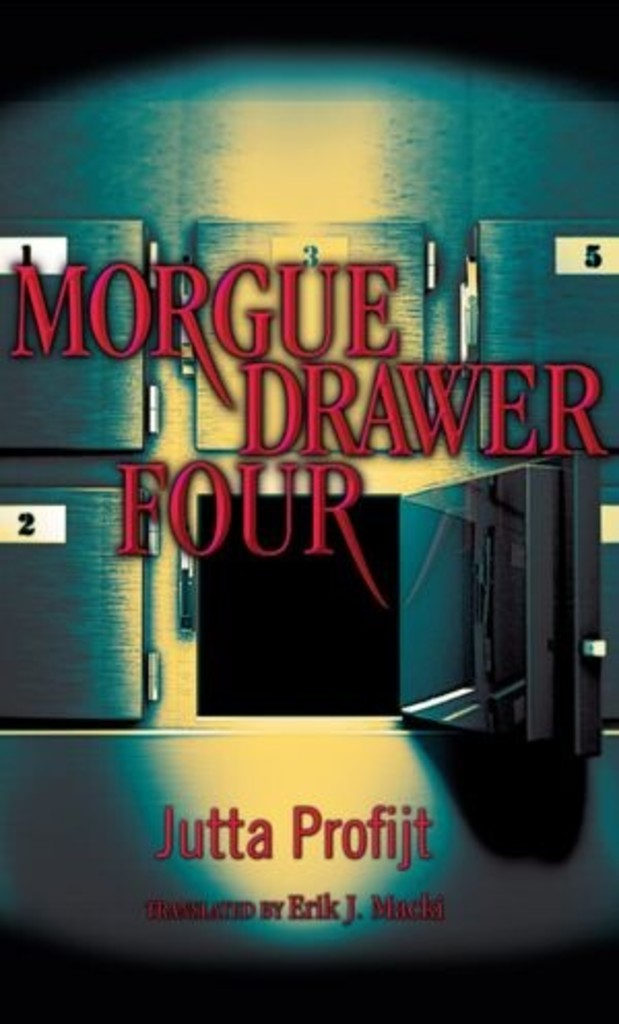Can you tell me more about the genre of the book based on the cover design? Based on the ominous cover design featuring a dark morgue hallway, the book 'Morgue Drawer Four' likely falls into the mystery and thriller genres. The visual elements suggest a plot that revolves around suspense, crime-solving, and possibly supernatural occurrences, perfect for readers who enjoy a gripping, edge-of-your-seat narrative. 